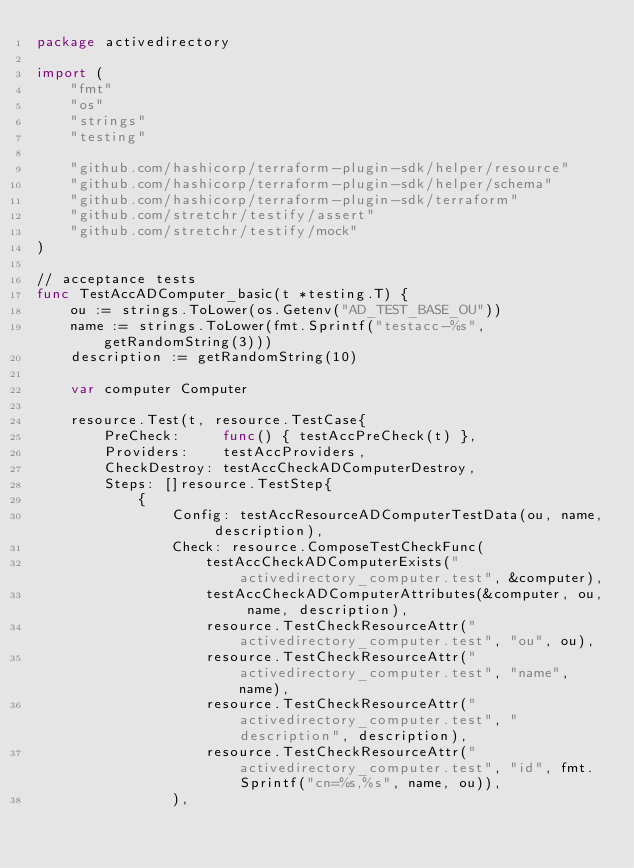Convert code to text. <code><loc_0><loc_0><loc_500><loc_500><_Go_>package activedirectory

import (
	"fmt"
	"os"
	"strings"
	"testing"

	"github.com/hashicorp/terraform-plugin-sdk/helper/resource"
	"github.com/hashicorp/terraform-plugin-sdk/helper/schema"
	"github.com/hashicorp/terraform-plugin-sdk/terraform"
	"github.com/stretchr/testify/assert"
	"github.com/stretchr/testify/mock"
)

// acceptance tests
func TestAccADComputer_basic(t *testing.T) {
	ou := strings.ToLower(os.Getenv("AD_TEST_BASE_OU"))
	name := strings.ToLower(fmt.Sprintf("testacc-%s", getRandomString(3)))
	description := getRandomString(10)

	var computer Computer

	resource.Test(t, resource.TestCase{
		PreCheck:     func() { testAccPreCheck(t) },
		Providers:    testAccProviders,
		CheckDestroy: testAccCheckADComputerDestroy,
		Steps: []resource.TestStep{
			{
				Config: testAccResourceADComputerTestData(ou, name, description),
				Check: resource.ComposeTestCheckFunc(
					testAccCheckADComputerExists("activedirectory_computer.test", &computer),
					testAccCheckADComputerAttributes(&computer, ou, name, description),
					resource.TestCheckResourceAttr("activedirectory_computer.test", "ou", ou),
					resource.TestCheckResourceAttr("activedirectory_computer.test", "name", name),
					resource.TestCheckResourceAttr("activedirectory_computer.test", "description", description),
					resource.TestCheckResourceAttr("activedirectory_computer.test", "id", fmt.Sprintf("cn=%s,%s", name, ou)),
				),</code> 